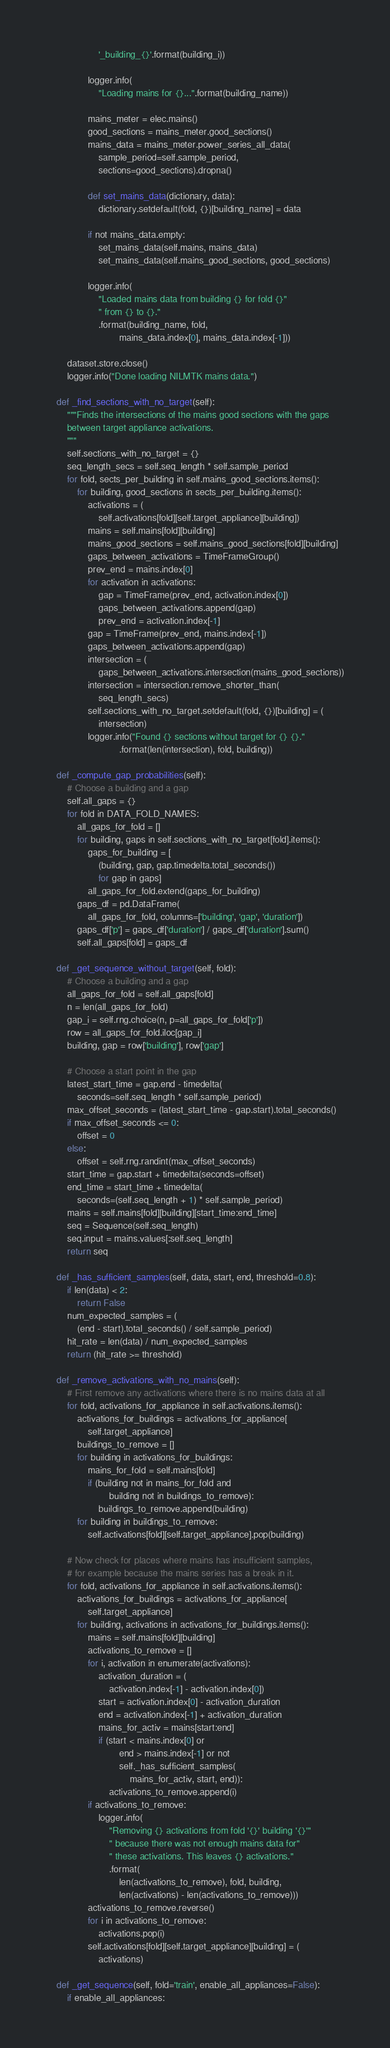Convert code to text. <code><loc_0><loc_0><loc_500><loc_500><_Python_>                    '_building_{}'.format(building_i))

                logger.info(
                    "Loading mains for {}...".format(building_name))

                mains_meter = elec.mains()
                good_sections = mains_meter.good_sections()
                mains_data = mains_meter.power_series_all_data(
                    sample_period=self.sample_period,
                    sections=good_sections).dropna()

                def set_mains_data(dictionary, data):
                    dictionary.setdefault(fold, {})[building_name] = data

                if not mains_data.empty:
                    set_mains_data(self.mains, mains_data)
                    set_mains_data(self.mains_good_sections, good_sections)

                logger.info(
                    "Loaded mains data from building {} for fold {}"
                    " from {} to {}."
                    .format(building_name, fold,
                            mains_data.index[0], mains_data.index[-1]))

        dataset.store.close()
        logger.info("Done loading NILMTK mains data.")

    def _find_sections_with_no_target(self):
        """Finds the intersections of the mains good sections with the gaps
        between target appliance activations.
        """
        self.sections_with_no_target = {}
        seq_length_secs = self.seq_length * self.sample_period
        for fold, sects_per_building in self.mains_good_sections.items():
            for building, good_sections in sects_per_building.items():
                activations = (
                    self.activations[fold][self.target_appliance][building])
                mains = self.mains[fold][building]
                mains_good_sections = self.mains_good_sections[fold][building]
                gaps_between_activations = TimeFrameGroup()
                prev_end = mains.index[0]
                for activation in activations:
                    gap = TimeFrame(prev_end, activation.index[0])
                    gaps_between_activations.append(gap)
                    prev_end = activation.index[-1]
                gap = TimeFrame(prev_end, mains.index[-1])
                gaps_between_activations.append(gap)
                intersection = (
                    gaps_between_activations.intersection(mains_good_sections))
                intersection = intersection.remove_shorter_than(
                    seq_length_secs)
                self.sections_with_no_target.setdefault(fold, {})[building] = (
                    intersection)
                logger.info("Found {} sections without target for {} {}."
                            .format(len(intersection), fold, building))

    def _compute_gap_probabilities(self):
        # Choose a building and a gap
        self.all_gaps = {}
        for fold in DATA_FOLD_NAMES:
            all_gaps_for_fold = []
            for building, gaps in self.sections_with_no_target[fold].items():
                gaps_for_building = [
                    (building, gap, gap.timedelta.total_seconds())
                    for gap in gaps]
                all_gaps_for_fold.extend(gaps_for_building)
            gaps_df = pd.DataFrame(
                all_gaps_for_fold, columns=['building', 'gap', 'duration'])
            gaps_df['p'] = gaps_df['duration'] / gaps_df['duration'].sum()
            self.all_gaps[fold] = gaps_df

    def _get_sequence_without_target(self, fold):
        # Choose a building and a gap
        all_gaps_for_fold = self.all_gaps[fold]
        n = len(all_gaps_for_fold)
        gap_i = self.rng.choice(n, p=all_gaps_for_fold['p'])
        row = all_gaps_for_fold.iloc[gap_i]
        building, gap = row['building'], row['gap']

        # Choose a start point in the gap
        latest_start_time = gap.end - timedelta(
            seconds=self.seq_length * self.sample_period)
        max_offset_seconds = (latest_start_time - gap.start).total_seconds()
        if max_offset_seconds <= 0:
            offset = 0
        else:
            offset = self.rng.randint(max_offset_seconds)
        start_time = gap.start + timedelta(seconds=offset)
        end_time = start_time + timedelta(
            seconds=(self.seq_length + 1) * self.sample_period)
        mains = self.mains[fold][building][start_time:end_time]
        seq = Sequence(self.seq_length)
        seq.input = mains.values[:self.seq_length]
        return seq

    def _has_sufficient_samples(self, data, start, end, threshold=0.8):
        if len(data) < 2:
            return False
        num_expected_samples = (
            (end - start).total_seconds() / self.sample_period)
        hit_rate = len(data) / num_expected_samples
        return (hit_rate >= threshold)

    def _remove_activations_with_no_mains(self):
        # First remove any activations where there is no mains data at all
        for fold, activations_for_appliance in self.activations.items():
            activations_for_buildings = activations_for_appliance[
                self.target_appliance]
            buildings_to_remove = []
            for building in activations_for_buildings:
                mains_for_fold = self.mains[fold]
                if (building not in mains_for_fold and
                        building not in buildings_to_remove):
                    buildings_to_remove.append(building)
            for building in buildings_to_remove:
                self.activations[fold][self.target_appliance].pop(building)

        # Now check for places where mains has insufficient samples,
        # for example because the mains series has a break in it.
        for fold, activations_for_appliance in self.activations.items():
            activations_for_buildings = activations_for_appliance[
                self.target_appliance]
            for building, activations in activations_for_buildings.items():
                mains = self.mains[fold][building]
                activations_to_remove = []
                for i, activation in enumerate(activations):
                    activation_duration = (
                        activation.index[-1] - activation.index[0])
                    start = activation.index[0] - activation_duration
                    end = activation.index[-1] + activation_duration
                    mains_for_activ = mains[start:end]
                    if (start < mains.index[0] or
                            end > mains.index[-1] or not
                            self._has_sufficient_samples(
                                mains_for_activ, start, end)):
                        activations_to_remove.append(i)
                if activations_to_remove:
                    logger.info(
                        "Removing {} activations from fold '{}' building '{}'"
                        " because there was not enough mains data for"
                        " these activations. This leaves {} activations."
                        .format(
                            len(activations_to_remove), fold, building,
                            len(activations) - len(activations_to_remove)))
                activations_to_remove.reverse()
                for i in activations_to_remove:
                    activations.pop(i)
                self.activations[fold][self.target_appliance][building] = (
                    activations)

    def _get_sequence(self, fold='train', enable_all_appliances=False):
        if enable_all_appliances:</code> 